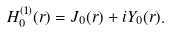<formula> <loc_0><loc_0><loc_500><loc_500>H _ { 0 } ^ { ( 1 ) } ( r ) = J _ { 0 } ( r ) + i Y _ { 0 } ( r ) .</formula> 